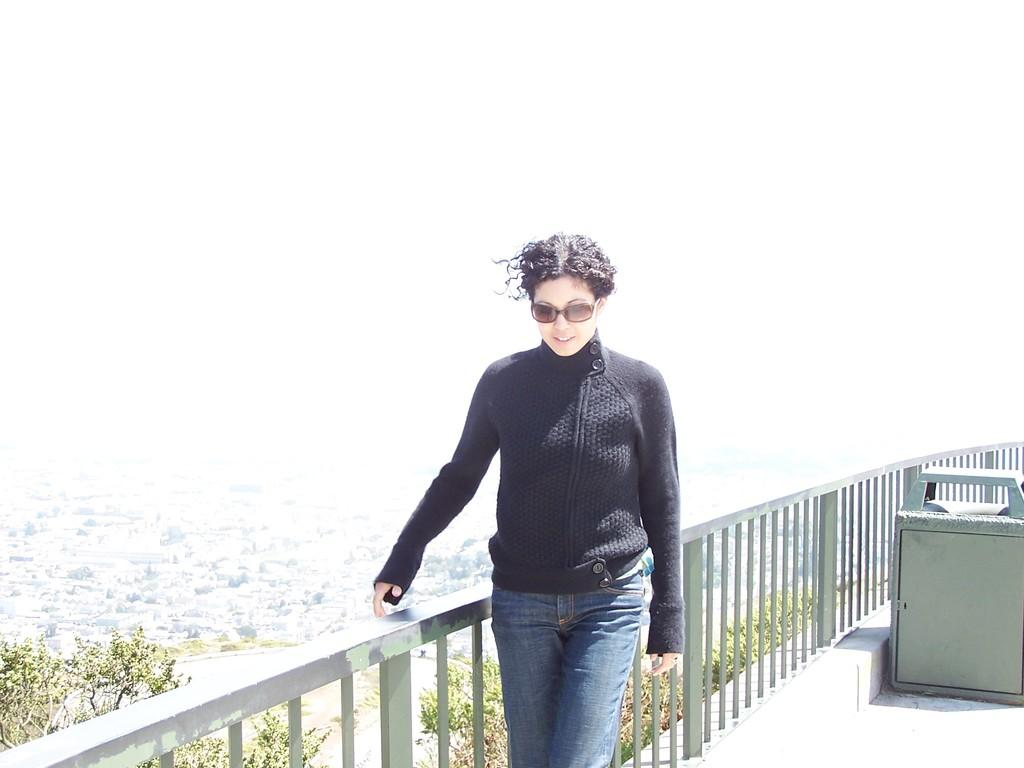Who is present in the image? There is a woman in the image. What is the woman wearing? The woman is wearing a black T-shirt. Where is the woman standing in relation to the railing? The woman is standing beside an iron railing. What can be seen in the background of the image? There are trees in the background of the image. What type of brass instrument is the woman playing in the image? There is no brass instrument present in the image; the woman is simply standing beside an iron railing. 